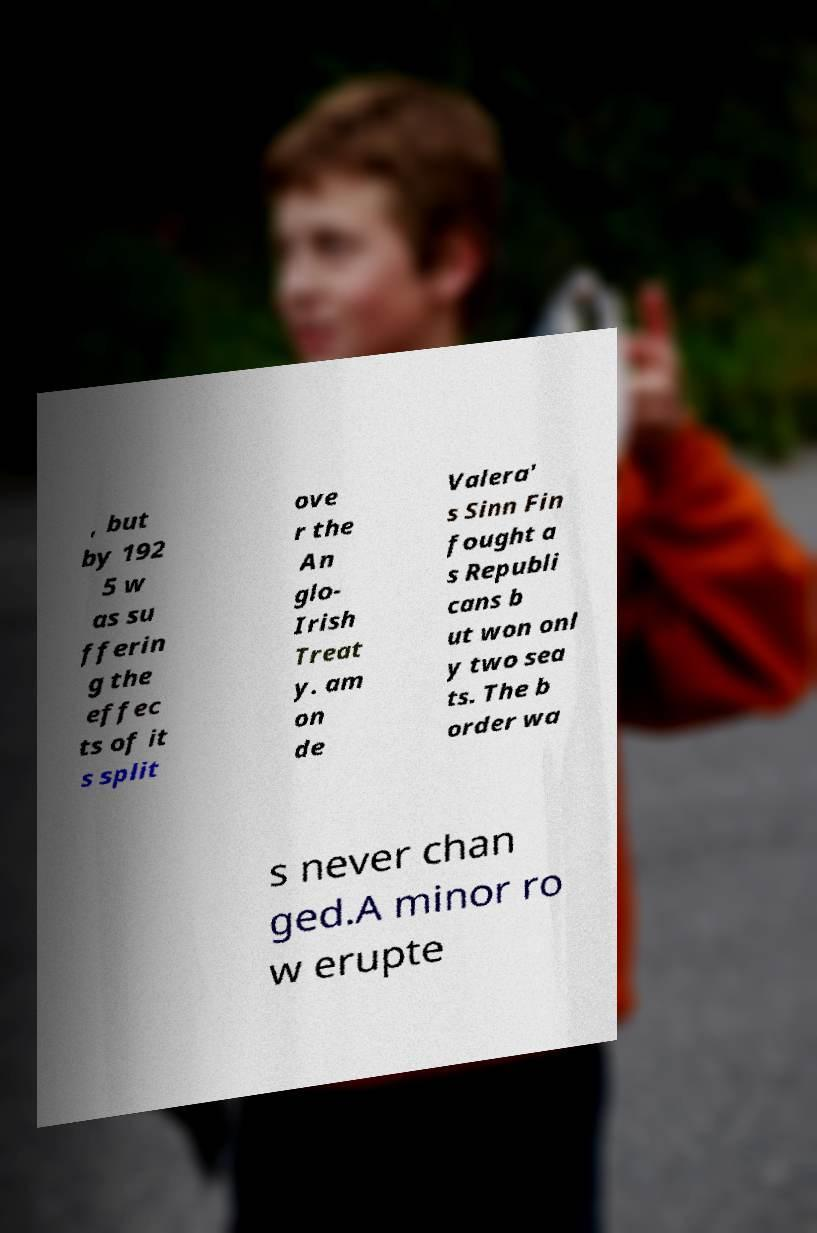I need the written content from this picture converted into text. Can you do that? , but by 192 5 w as su fferin g the effec ts of it s split ove r the An glo- Irish Treat y. am on de Valera' s Sinn Fin fought a s Republi cans b ut won onl y two sea ts. The b order wa s never chan ged.A minor ro w erupte 